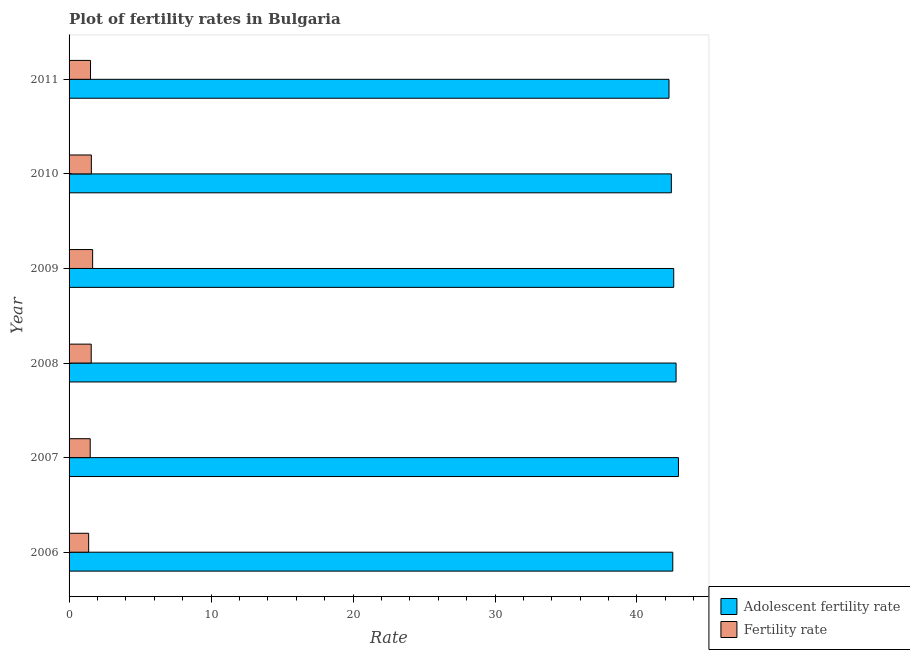Are the number of bars on each tick of the Y-axis equal?
Keep it short and to the point. Yes. What is the label of the 6th group of bars from the top?
Your response must be concise. 2006. What is the fertility rate in 2011?
Your response must be concise. 1.51. Across all years, what is the maximum fertility rate?
Offer a terse response. 1.66. Across all years, what is the minimum adolescent fertility rate?
Offer a terse response. 42.26. In which year was the fertility rate maximum?
Provide a succinct answer. 2009. What is the total adolescent fertility rate in the graph?
Offer a very short reply. 255.46. What is the difference between the fertility rate in 2007 and that in 2008?
Provide a succinct answer. -0.07. What is the difference between the adolescent fertility rate in 2009 and the fertility rate in 2008?
Your answer should be compact. 41.03. What is the average adolescent fertility rate per year?
Ensure brevity in your answer.  42.58. In the year 2007, what is the difference between the fertility rate and adolescent fertility rate?
Make the answer very short. -41.43. In how many years, is the adolescent fertility rate greater than 6 ?
Provide a succinct answer. 6. Is the fertility rate in 2008 less than that in 2009?
Your answer should be compact. Yes. Is the difference between the fertility rate in 2007 and 2008 greater than the difference between the adolescent fertility rate in 2007 and 2008?
Your answer should be compact. No. What is the difference between the highest and the second highest fertility rate?
Ensure brevity in your answer.  0.09. What is the difference between the highest and the lowest adolescent fertility rate?
Your answer should be compact. 0.66. In how many years, is the adolescent fertility rate greater than the average adolescent fertility rate taken over all years?
Provide a short and direct response. 3. What does the 2nd bar from the top in 2011 represents?
Your answer should be compact. Adolescent fertility rate. What does the 2nd bar from the bottom in 2006 represents?
Offer a very short reply. Fertility rate. How many bars are there?
Make the answer very short. 12. What is the difference between two consecutive major ticks on the X-axis?
Your answer should be very brief. 10. Are the values on the major ticks of X-axis written in scientific E-notation?
Offer a terse response. No. Does the graph contain any zero values?
Your response must be concise. No. Does the graph contain grids?
Your response must be concise. No. Where does the legend appear in the graph?
Your answer should be compact. Bottom right. How are the legend labels stacked?
Keep it short and to the point. Vertical. What is the title of the graph?
Give a very brief answer. Plot of fertility rates in Bulgaria. Does "Age 65(female)" appear as one of the legend labels in the graph?
Your answer should be very brief. No. What is the label or title of the X-axis?
Make the answer very short. Rate. What is the label or title of the Y-axis?
Provide a succinct answer. Year. What is the Rate in Adolescent fertility rate in 2006?
Provide a succinct answer. 42.52. What is the Rate in Fertility rate in 2006?
Your response must be concise. 1.38. What is the Rate in Adolescent fertility rate in 2007?
Give a very brief answer. 42.92. What is the Rate in Fertility rate in 2007?
Keep it short and to the point. 1.49. What is the Rate of Adolescent fertility rate in 2008?
Give a very brief answer. 42.75. What is the Rate in Fertility rate in 2008?
Give a very brief answer. 1.56. What is the Rate of Adolescent fertility rate in 2009?
Ensure brevity in your answer.  42.59. What is the Rate of Fertility rate in 2009?
Offer a terse response. 1.66. What is the Rate in Adolescent fertility rate in 2010?
Your answer should be very brief. 42.42. What is the Rate of Fertility rate in 2010?
Keep it short and to the point. 1.57. What is the Rate in Adolescent fertility rate in 2011?
Your answer should be very brief. 42.26. What is the Rate of Fertility rate in 2011?
Ensure brevity in your answer.  1.51. Across all years, what is the maximum Rate in Adolescent fertility rate?
Your answer should be compact. 42.92. Across all years, what is the maximum Rate in Fertility rate?
Your answer should be compact. 1.66. Across all years, what is the minimum Rate in Adolescent fertility rate?
Offer a very short reply. 42.26. Across all years, what is the minimum Rate of Fertility rate?
Ensure brevity in your answer.  1.38. What is the total Rate of Adolescent fertility rate in the graph?
Provide a succinct answer. 255.46. What is the total Rate in Fertility rate in the graph?
Provide a short and direct response. 9.17. What is the difference between the Rate of Adolescent fertility rate in 2006 and that in 2007?
Ensure brevity in your answer.  -0.4. What is the difference between the Rate of Fertility rate in 2006 and that in 2007?
Keep it short and to the point. -0.11. What is the difference between the Rate in Adolescent fertility rate in 2006 and that in 2008?
Your response must be concise. -0.23. What is the difference between the Rate in Fertility rate in 2006 and that in 2008?
Your answer should be compact. -0.18. What is the difference between the Rate of Adolescent fertility rate in 2006 and that in 2009?
Give a very brief answer. -0.07. What is the difference between the Rate in Fertility rate in 2006 and that in 2009?
Offer a terse response. -0.28. What is the difference between the Rate in Adolescent fertility rate in 2006 and that in 2010?
Your answer should be very brief. 0.1. What is the difference between the Rate of Fertility rate in 2006 and that in 2010?
Offer a very short reply. -0.19. What is the difference between the Rate of Adolescent fertility rate in 2006 and that in 2011?
Your response must be concise. 0.27. What is the difference between the Rate in Fertility rate in 2006 and that in 2011?
Give a very brief answer. -0.13. What is the difference between the Rate of Adolescent fertility rate in 2007 and that in 2008?
Make the answer very short. 0.17. What is the difference between the Rate of Fertility rate in 2007 and that in 2008?
Offer a very short reply. -0.07. What is the difference between the Rate of Adolescent fertility rate in 2007 and that in 2009?
Your response must be concise. 0.33. What is the difference between the Rate in Fertility rate in 2007 and that in 2009?
Provide a short and direct response. -0.17. What is the difference between the Rate in Adolescent fertility rate in 2007 and that in 2010?
Offer a terse response. 0.5. What is the difference between the Rate in Fertility rate in 2007 and that in 2010?
Make the answer very short. -0.08. What is the difference between the Rate of Adolescent fertility rate in 2007 and that in 2011?
Provide a succinct answer. 0.66. What is the difference between the Rate in Fertility rate in 2007 and that in 2011?
Make the answer very short. -0.02. What is the difference between the Rate in Adolescent fertility rate in 2008 and that in 2009?
Ensure brevity in your answer.  0.17. What is the difference between the Rate in Fertility rate in 2008 and that in 2009?
Your response must be concise. -0.1. What is the difference between the Rate in Adolescent fertility rate in 2008 and that in 2010?
Make the answer very short. 0.33. What is the difference between the Rate in Fertility rate in 2008 and that in 2010?
Keep it short and to the point. -0.01. What is the difference between the Rate of Adolescent fertility rate in 2008 and that in 2011?
Offer a terse response. 0.5. What is the difference between the Rate in Adolescent fertility rate in 2009 and that in 2010?
Make the answer very short. 0.17. What is the difference between the Rate in Fertility rate in 2009 and that in 2010?
Offer a very short reply. 0.09. What is the difference between the Rate of Adolescent fertility rate in 2009 and that in 2011?
Provide a succinct answer. 0.33. What is the difference between the Rate of Fertility rate in 2009 and that in 2011?
Offer a very short reply. 0.15. What is the difference between the Rate in Adolescent fertility rate in 2010 and that in 2011?
Offer a very short reply. 0.17. What is the difference between the Rate in Fertility rate in 2010 and that in 2011?
Offer a terse response. 0.06. What is the difference between the Rate in Adolescent fertility rate in 2006 and the Rate in Fertility rate in 2007?
Your response must be concise. 41.03. What is the difference between the Rate in Adolescent fertility rate in 2006 and the Rate in Fertility rate in 2008?
Your answer should be very brief. 40.96. What is the difference between the Rate in Adolescent fertility rate in 2006 and the Rate in Fertility rate in 2009?
Keep it short and to the point. 40.86. What is the difference between the Rate in Adolescent fertility rate in 2006 and the Rate in Fertility rate in 2010?
Your response must be concise. 40.95. What is the difference between the Rate of Adolescent fertility rate in 2006 and the Rate of Fertility rate in 2011?
Keep it short and to the point. 41.01. What is the difference between the Rate of Adolescent fertility rate in 2007 and the Rate of Fertility rate in 2008?
Keep it short and to the point. 41.36. What is the difference between the Rate of Adolescent fertility rate in 2007 and the Rate of Fertility rate in 2009?
Your answer should be compact. 41.26. What is the difference between the Rate in Adolescent fertility rate in 2007 and the Rate in Fertility rate in 2010?
Provide a short and direct response. 41.35. What is the difference between the Rate in Adolescent fertility rate in 2007 and the Rate in Fertility rate in 2011?
Your answer should be very brief. 41.41. What is the difference between the Rate in Adolescent fertility rate in 2008 and the Rate in Fertility rate in 2009?
Offer a very short reply. 41.09. What is the difference between the Rate in Adolescent fertility rate in 2008 and the Rate in Fertility rate in 2010?
Your answer should be very brief. 41.18. What is the difference between the Rate in Adolescent fertility rate in 2008 and the Rate in Fertility rate in 2011?
Ensure brevity in your answer.  41.24. What is the difference between the Rate of Adolescent fertility rate in 2009 and the Rate of Fertility rate in 2010?
Ensure brevity in your answer.  41.02. What is the difference between the Rate in Adolescent fertility rate in 2009 and the Rate in Fertility rate in 2011?
Provide a succinct answer. 41.08. What is the difference between the Rate of Adolescent fertility rate in 2010 and the Rate of Fertility rate in 2011?
Keep it short and to the point. 40.91. What is the average Rate of Adolescent fertility rate per year?
Your response must be concise. 42.58. What is the average Rate of Fertility rate per year?
Ensure brevity in your answer.  1.53. In the year 2006, what is the difference between the Rate of Adolescent fertility rate and Rate of Fertility rate?
Make the answer very short. 41.14. In the year 2007, what is the difference between the Rate in Adolescent fertility rate and Rate in Fertility rate?
Offer a terse response. 41.43. In the year 2008, what is the difference between the Rate in Adolescent fertility rate and Rate in Fertility rate?
Provide a short and direct response. 41.19. In the year 2009, what is the difference between the Rate of Adolescent fertility rate and Rate of Fertility rate?
Offer a terse response. 40.93. In the year 2010, what is the difference between the Rate in Adolescent fertility rate and Rate in Fertility rate?
Ensure brevity in your answer.  40.85. In the year 2011, what is the difference between the Rate of Adolescent fertility rate and Rate of Fertility rate?
Make the answer very short. 40.75. What is the ratio of the Rate in Adolescent fertility rate in 2006 to that in 2007?
Offer a very short reply. 0.99. What is the ratio of the Rate of Fertility rate in 2006 to that in 2007?
Make the answer very short. 0.93. What is the ratio of the Rate of Fertility rate in 2006 to that in 2008?
Give a very brief answer. 0.88. What is the ratio of the Rate in Fertility rate in 2006 to that in 2009?
Your answer should be compact. 0.83. What is the ratio of the Rate of Adolescent fertility rate in 2006 to that in 2010?
Keep it short and to the point. 1. What is the ratio of the Rate of Fertility rate in 2006 to that in 2010?
Offer a terse response. 0.88. What is the ratio of the Rate in Fertility rate in 2006 to that in 2011?
Offer a terse response. 0.91. What is the ratio of the Rate of Adolescent fertility rate in 2007 to that in 2008?
Ensure brevity in your answer.  1. What is the ratio of the Rate of Fertility rate in 2007 to that in 2008?
Provide a short and direct response. 0.96. What is the ratio of the Rate of Fertility rate in 2007 to that in 2009?
Provide a short and direct response. 0.9. What is the ratio of the Rate in Adolescent fertility rate in 2007 to that in 2010?
Your response must be concise. 1.01. What is the ratio of the Rate of Fertility rate in 2007 to that in 2010?
Ensure brevity in your answer.  0.95. What is the ratio of the Rate in Adolescent fertility rate in 2007 to that in 2011?
Offer a terse response. 1.02. What is the ratio of the Rate of Fertility rate in 2007 to that in 2011?
Keep it short and to the point. 0.99. What is the ratio of the Rate of Adolescent fertility rate in 2008 to that in 2009?
Provide a short and direct response. 1. What is the ratio of the Rate in Fertility rate in 2008 to that in 2009?
Offer a very short reply. 0.94. What is the ratio of the Rate in Adolescent fertility rate in 2008 to that in 2011?
Give a very brief answer. 1.01. What is the ratio of the Rate in Fertility rate in 2008 to that in 2011?
Give a very brief answer. 1.03. What is the ratio of the Rate in Fertility rate in 2009 to that in 2010?
Offer a very short reply. 1.06. What is the ratio of the Rate in Adolescent fertility rate in 2009 to that in 2011?
Keep it short and to the point. 1.01. What is the ratio of the Rate of Fertility rate in 2009 to that in 2011?
Make the answer very short. 1.1. What is the ratio of the Rate in Adolescent fertility rate in 2010 to that in 2011?
Offer a very short reply. 1. What is the ratio of the Rate in Fertility rate in 2010 to that in 2011?
Give a very brief answer. 1.04. What is the difference between the highest and the second highest Rate of Adolescent fertility rate?
Offer a very short reply. 0.17. What is the difference between the highest and the second highest Rate of Fertility rate?
Ensure brevity in your answer.  0.09. What is the difference between the highest and the lowest Rate of Adolescent fertility rate?
Offer a very short reply. 0.66. What is the difference between the highest and the lowest Rate in Fertility rate?
Your answer should be very brief. 0.28. 